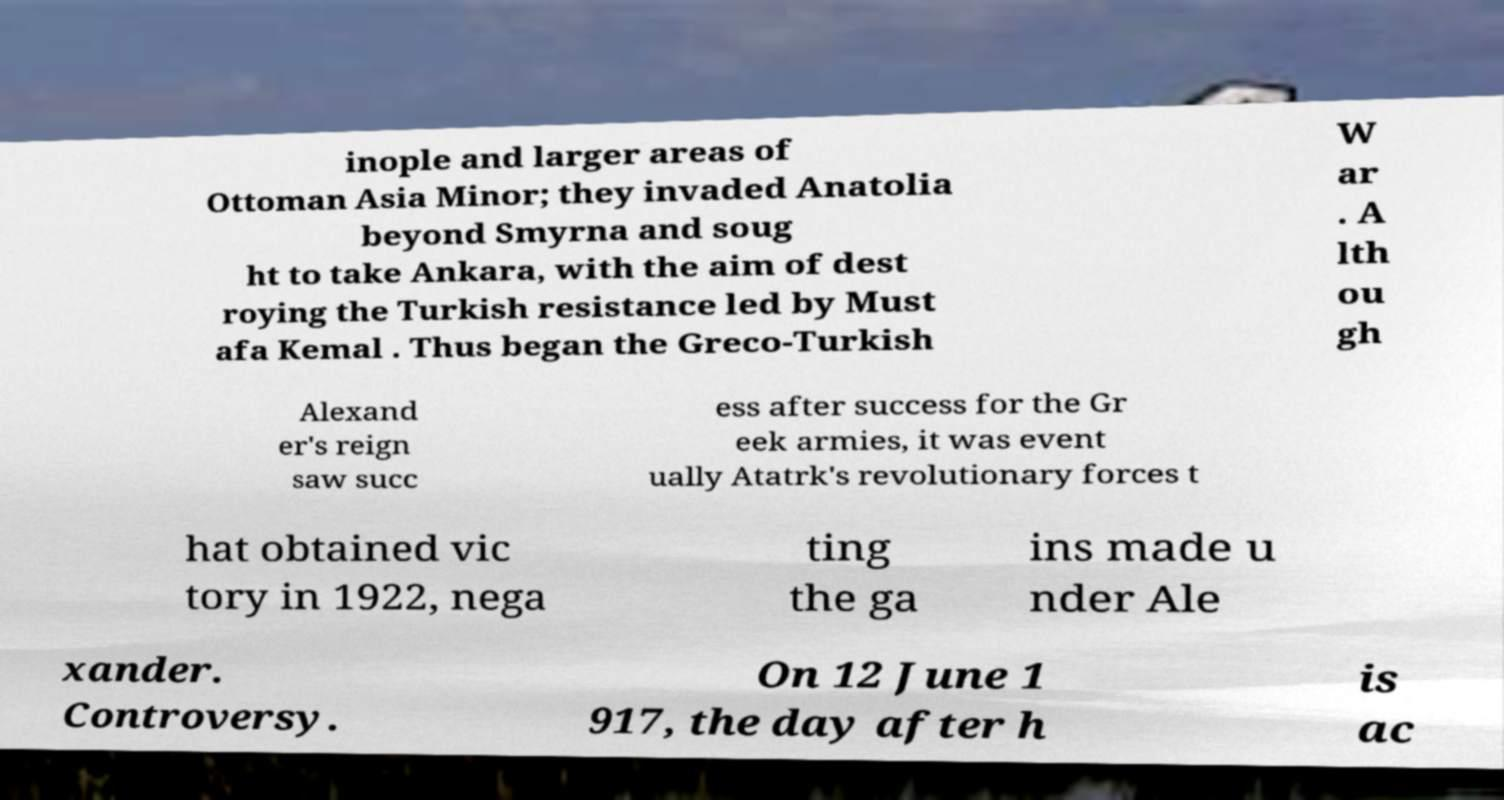Please identify and transcribe the text found in this image. inople and larger areas of Ottoman Asia Minor; they invaded Anatolia beyond Smyrna and soug ht to take Ankara, with the aim of dest roying the Turkish resistance led by Must afa Kemal . Thus began the Greco-Turkish W ar . A lth ou gh Alexand er's reign saw succ ess after success for the Gr eek armies, it was event ually Atatrk's revolutionary forces t hat obtained vic tory in 1922, nega ting the ga ins made u nder Ale xander. Controversy. On 12 June 1 917, the day after h is ac 